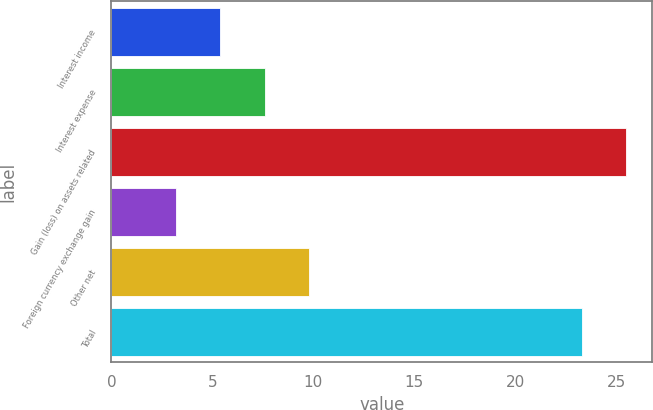<chart> <loc_0><loc_0><loc_500><loc_500><bar_chart><fcel>Interest income<fcel>Interest expense<fcel>Gain (loss) on assets related<fcel>Foreign currency exchange gain<fcel>Other net<fcel>Total<nl><fcel>5.4<fcel>7.6<fcel>25.5<fcel>3.2<fcel>9.8<fcel>23.3<nl></chart> 